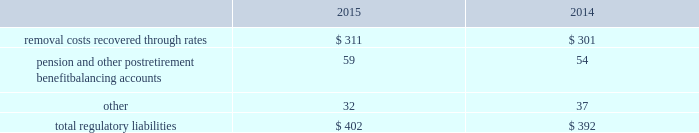The authorized costs of $ 76 are to be recovered via a surcharge over a twenty-year period beginning october 2012 .
Surcharges collected as of december 31 , 2015 and 2014 were $ 4 and $ 5 , respectively .
In addition to the authorized costs , the company expects to incur additional costs totaling $ 34 , which will be recovered from contributions made by the california state coastal conservancy .
Contributions collected as of december 31 , 2015 and 2014 were $ 8 and $ 5 , respectively .
Regulatory balancing accounts accumulate differences between revenues recognized and authorized revenue requirements until they are collected from customers or are refunded .
Regulatory balancing accounts include low income programs and purchased power and water accounts .
Debt expense is amortized over the lives of the respective issues .
Call premiums on the redemption of long- term debt , as well as unamortized debt expense , are deferred and amortized to the extent they will be recovered through future service rates .
Purchase premium recoverable through rates is primarily the recovery of the acquisition premiums related to an asset acquisition by the company 2019s california subsidiary during 2002 , and acquisitions in 2007 by the company 2019s new jersey subsidiary .
As authorized for recovery by the california and new jersey pucs , these costs are being amortized to depreciation and amortization in the consolidated statements of operations through november 2048 .
Tank painting costs are generally deferred and amortized to operations and maintenance expense in the consolidated statements of operations on a straight-line basis over periods ranging from five to fifteen years , as authorized by the regulatory authorities in their determination of rates charged for service .
Other regulatory assets include certain deferred business transformation costs , construction costs for treatment facilities , property tax stabilization , employee-related costs , business services project expenses , coastal water project costs , rate case expenditures and environmental remediation costs among others .
These costs are deferred because the amounts are being recovered in rates or are probable of recovery through rates in future periods .
Regulatory liabilities the regulatory liabilities generally represent probable future reductions in revenues associated with amounts that are to be credited or refunded to customers through the rate-making process .
The table summarizes the composition of regulatory liabilities as of december 31: .
Removal costs recovered through rates are estimated costs to retire assets at the end of their expected useful life that are recovered through customer rates over the life of the associated assets .
In december 2008 , the company 2019s subsidiary in new jersey , at the direction of the new jersey puc , began to depreciate $ 48 of the total balance into depreciation and amortization expense in the consolidated statements of operations via straight line amortization through november 2048 .
Pension and other postretirement benefit balancing accounts represent the difference between costs incurred and costs authorized by the puc 2019s that are expected to be refunded to customers. .
By how much did total regulatory liabilities increase from 2014 to 2015? 
Computations: ((402 - 392) / 392)
Answer: 0.02551. 